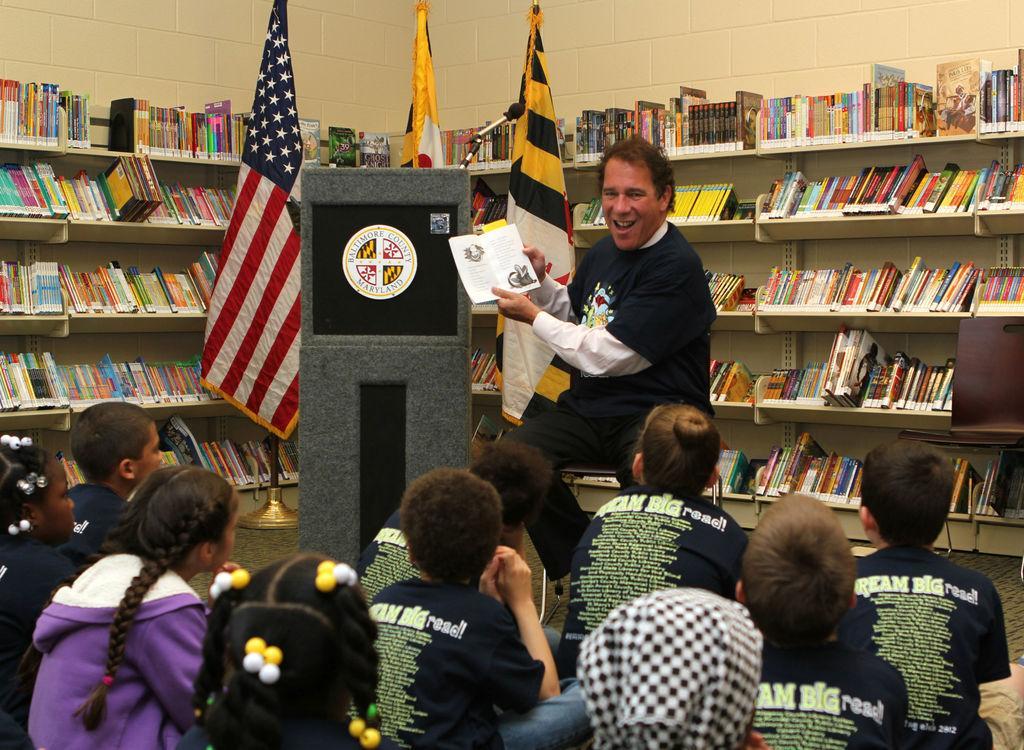In one or two sentences, can you explain what this image depicts? In this image I can see a person wearing black and white dress is sitting on a chair and holding a book in his hand. I can see a podium, and microphone, few flags and few racks with number of books in them and I can see few children sitting on the floor. In the background I can see the wall. 